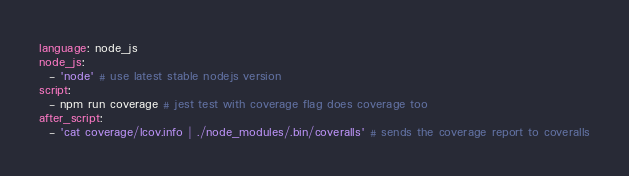<code> <loc_0><loc_0><loc_500><loc_500><_YAML_>language: node_js
node_js:
  - 'node' # use latest stable nodejs version
script:
  - npm run coverage # jest test with coverage flag does coverage too
after_script:
  - 'cat coverage/lcov.info | ./node_modules/.bin/coveralls' # sends the coverage report to coveralls</code> 